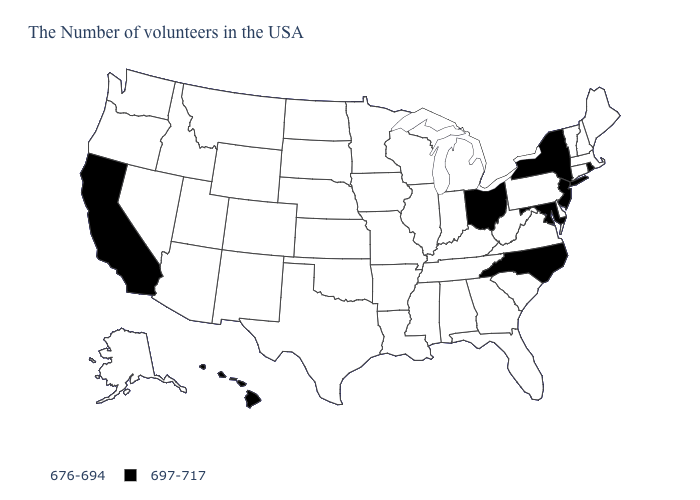What is the value of Georgia?
Short answer required. 676-694. What is the value of Alabama?
Be succinct. 676-694. What is the value of Delaware?
Write a very short answer. 676-694. Name the states that have a value in the range 697-717?
Short answer required. Rhode Island, New York, New Jersey, Maryland, North Carolina, Ohio, California, Hawaii. Is the legend a continuous bar?
Give a very brief answer. No. Name the states that have a value in the range 697-717?
Be succinct. Rhode Island, New York, New Jersey, Maryland, North Carolina, Ohio, California, Hawaii. What is the lowest value in the USA?
Be succinct. 676-694. Is the legend a continuous bar?
Keep it brief. No. Which states hav the highest value in the MidWest?
Quick response, please. Ohio. Name the states that have a value in the range 697-717?
Give a very brief answer. Rhode Island, New York, New Jersey, Maryland, North Carolina, Ohio, California, Hawaii. Which states have the lowest value in the USA?
Quick response, please. Maine, Massachusetts, New Hampshire, Vermont, Connecticut, Delaware, Pennsylvania, Virginia, South Carolina, West Virginia, Florida, Georgia, Michigan, Kentucky, Indiana, Alabama, Tennessee, Wisconsin, Illinois, Mississippi, Louisiana, Missouri, Arkansas, Minnesota, Iowa, Kansas, Nebraska, Oklahoma, Texas, South Dakota, North Dakota, Wyoming, Colorado, New Mexico, Utah, Montana, Arizona, Idaho, Nevada, Washington, Oregon, Alaska. What is the lowest value in states that border Texas?
Short answer required. 676-694. What is the value of Tennessee?
Give a very brief answer. 676-694. 